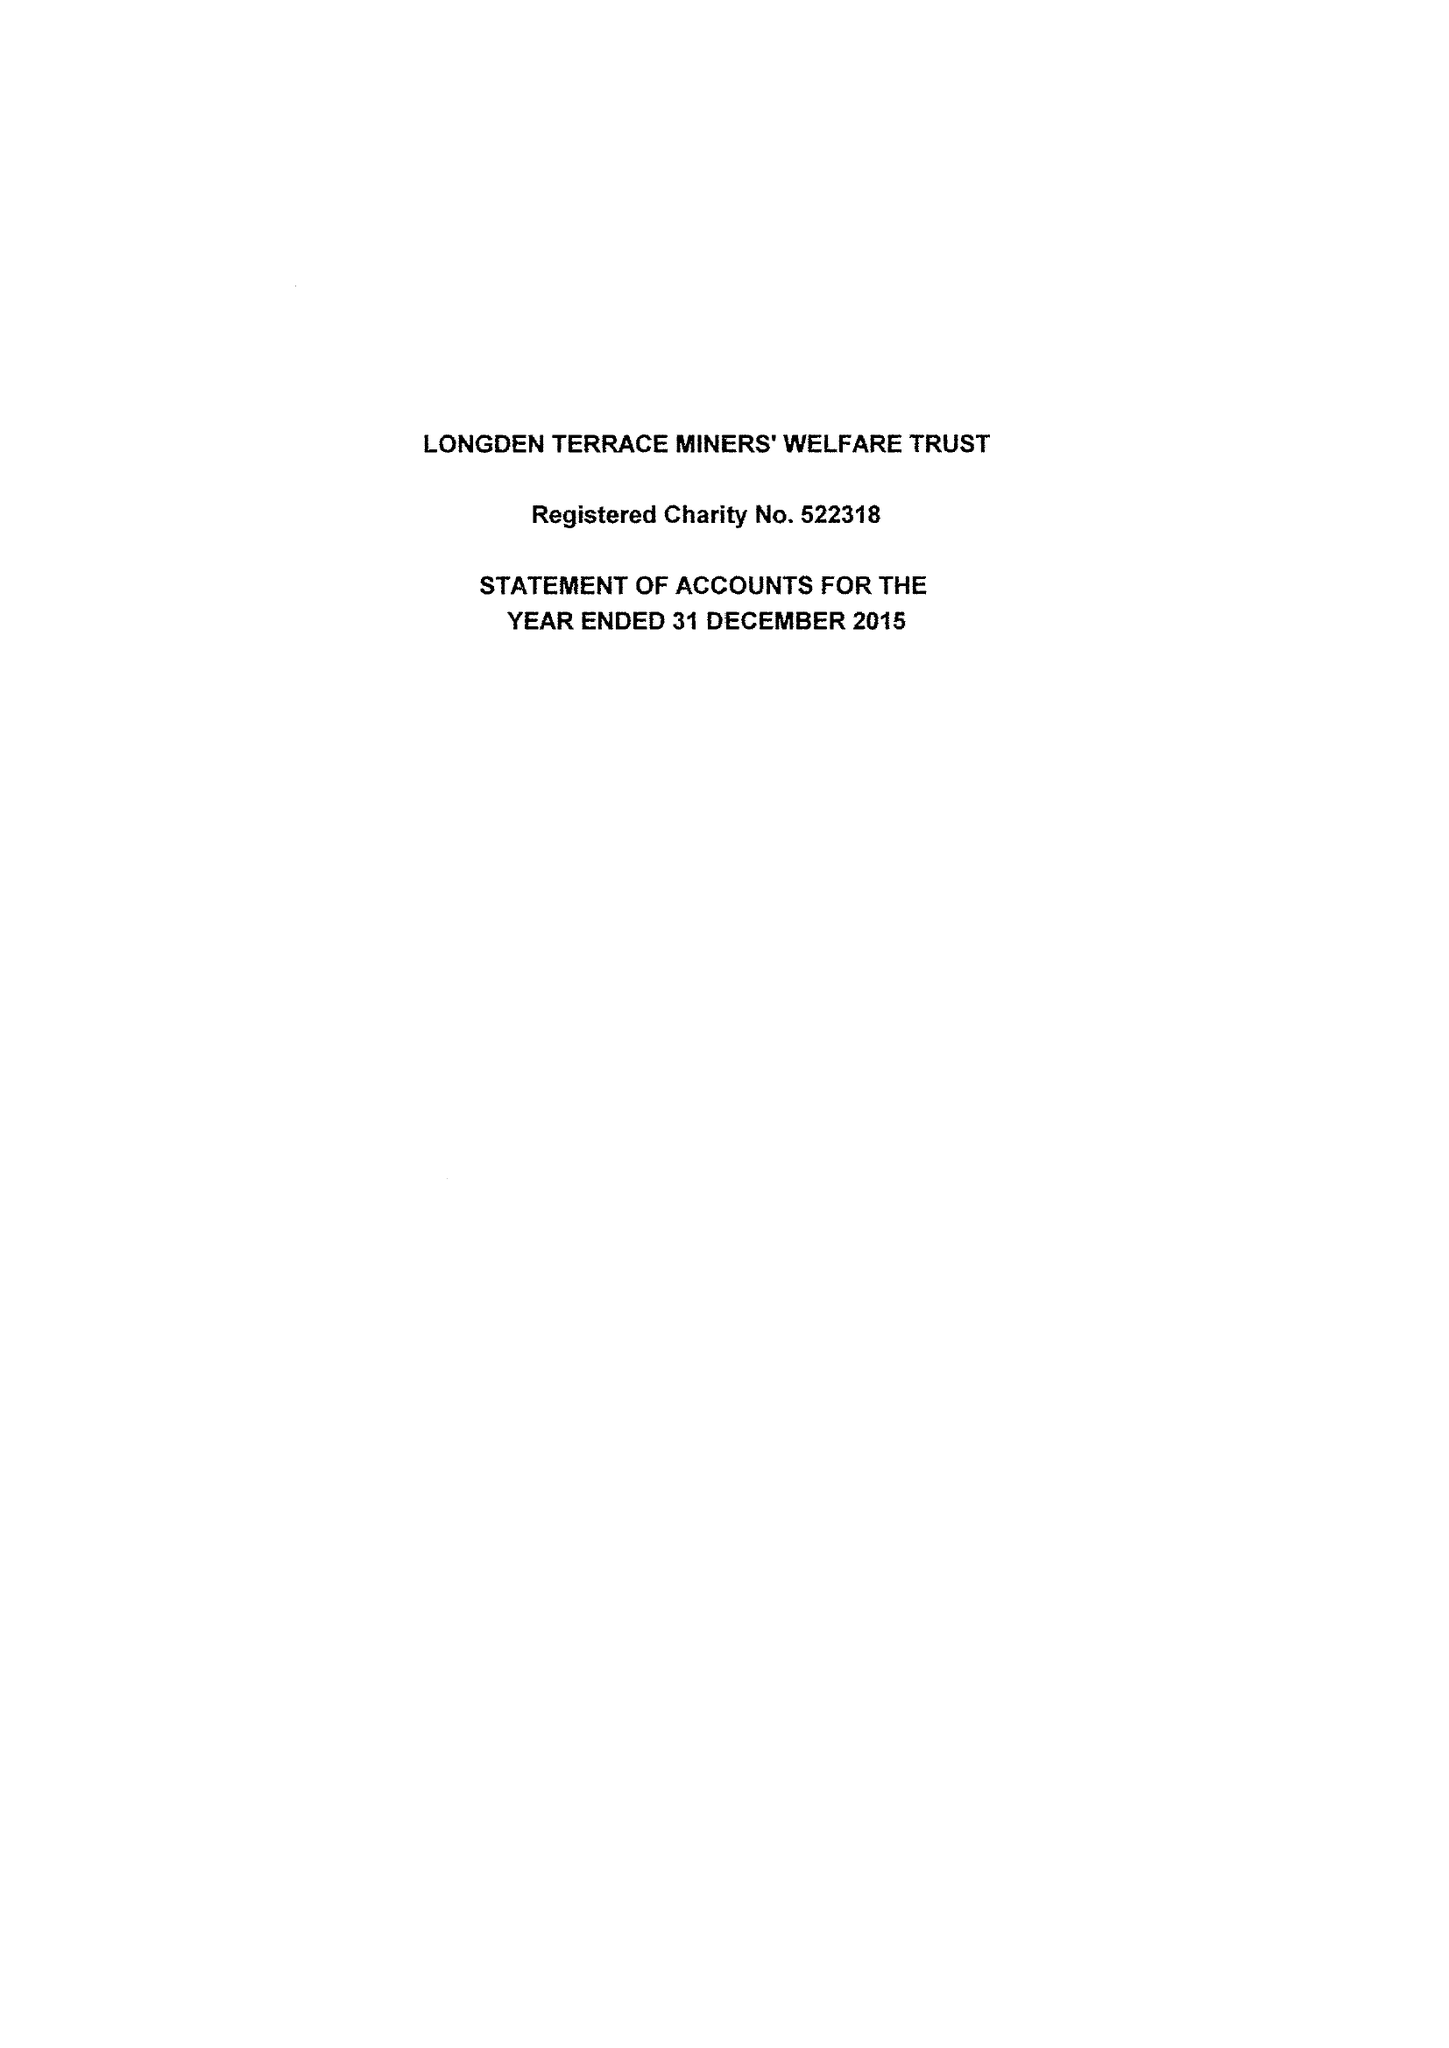What is the value for the address__postcode?
Answer the question using a single word or phrase. NG21 9JW 